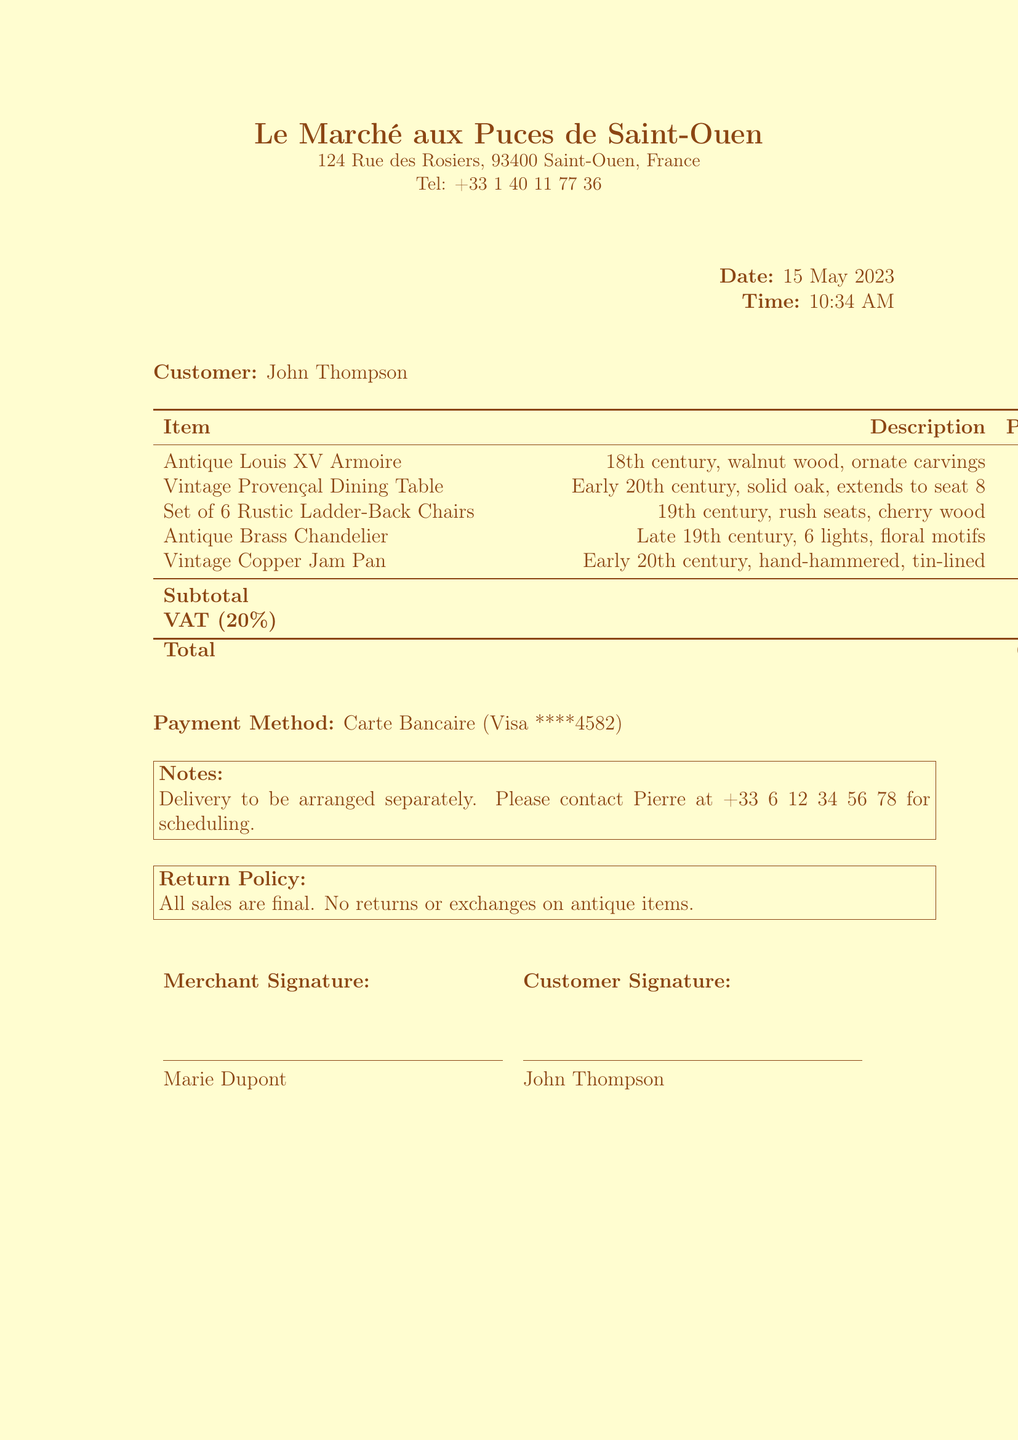What is the merchant name? The merchant name is listed at the top of the document and refers to the place of purchase.
Answer: Le Marché aux Puces de Saint-Ouen What is the total amount spent? The total amount reflects the total cost after subtotal and VAT calculations in the document.
Answer: 6756.00 Who is the customer? The name of the customer is provided directly in the document.
Answer: John Thompson What is the payment method used? The payment method is indicated in the document under the payment details section.
Answer: Carte Bancaire What is the VAT amount applied? The VAT amount is specified in the document along with the tax rate.
Answer: 1126.00 What date was the purchase made? The date of the purchase is clearly stated in the document.
Answer: 15 May 2023 How many items were purchased in total? The number of items is derived from counting the items listed in the receipt.
Answer: 5 Is there a return policy mentioned? The document explicitly states the return policy regarding sales.
Answer: All sales are final Who signed the merchant's section? The merchant's signature is provided at the bottom of the receipt.
Answer: Marie Dupont 